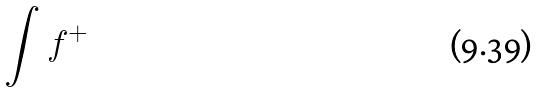Convert formula to latex. <formula><loc_0><loc_0><loc_500><loc_500>\int f ^ { + }</formula> 